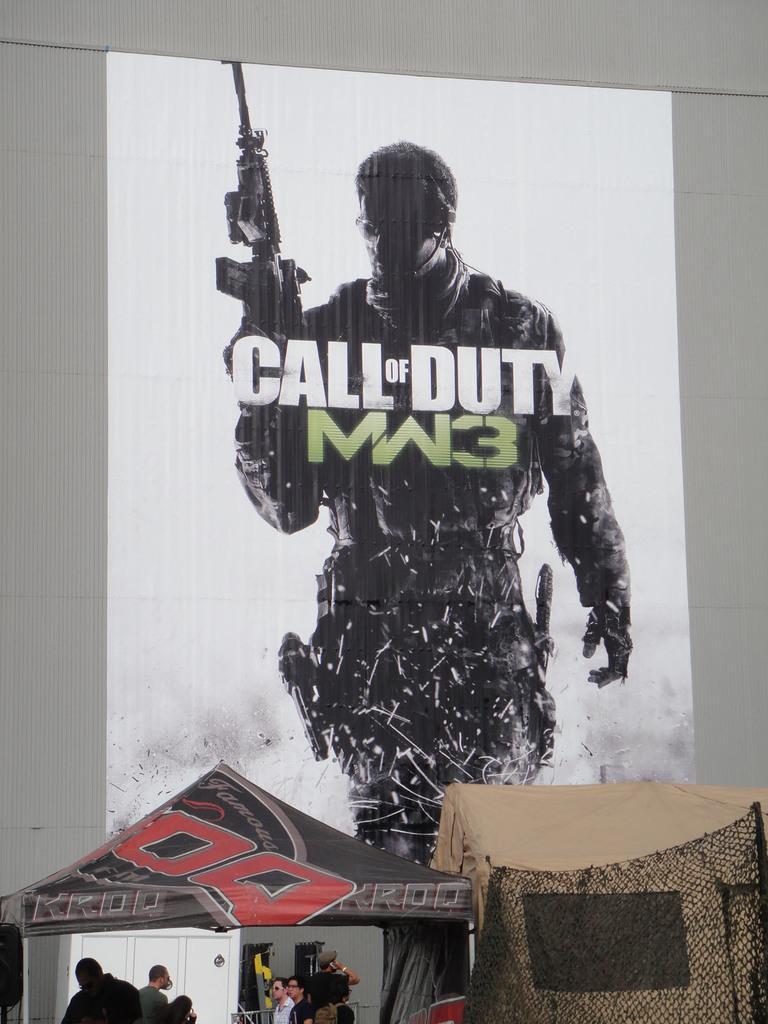Could you give a brief overview of what you see in this image? In this picture we can see people and tents and in the background we can see a poster on the wall. 